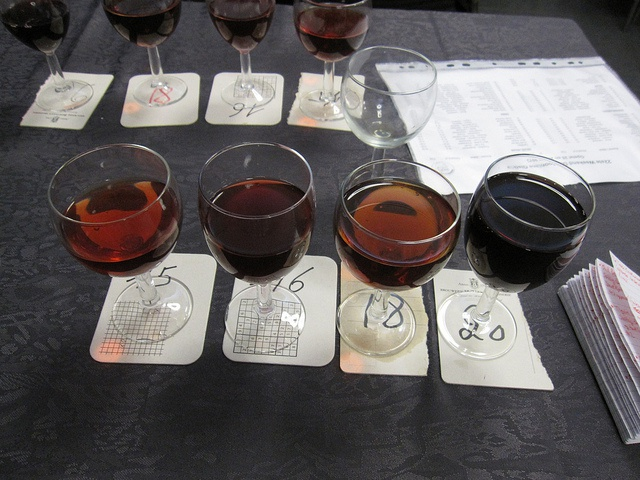Describe the objects in this image and their specific colors. I can see dining table in black, gray, lightgray, and darkgray tones, wine glass in black, maroon, darkgray, and gray tones, wine glass in black, gray, darkgray, and lightgray tones, wine glass in black, maroon, gray, and darkgray tones, and wine glass in black, lightgray, gray, and darkgray tones in this image. 